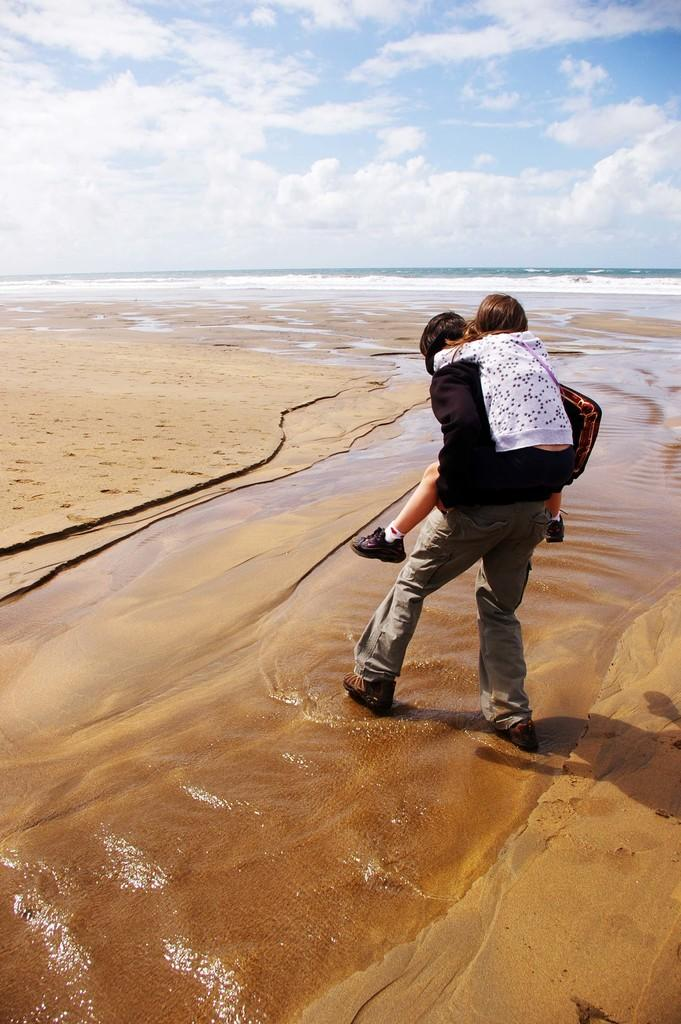What is the main action taking place in the image? There is a person carrying another person in the image. What is the setting of the image? They are walking in the water, and there is sand visible in the image. What can be seen in the background of the image? The background of the image includes water, and the sky is cloudy. What type of bells can be heard ringing in the image? There are no bells present in the image, and therefore no sound can be heard. 